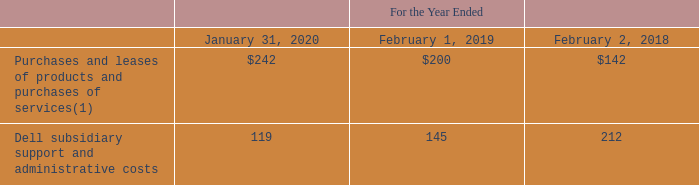We engaged with Dell in the following ongoing related party transactions, which resulted in costs to us:
• We purchase and lease products and purchase services from Dell.
• From time to time, we and Dell enter into agreements to collaborate on technology projects, and we pay Dell for services provided to us by Dell related to such projects.
• In certain geographic regions where we do not have an established legal entity, we contract with Dell subsidiaries for support services and support from Dell personnel who are managed by us. The costs incurred by Dell on our behalf related to these employees are charged to us with a mark-up intended to approximate costs that would have been incurred had we contracted for such services with an unrelated third party. These costs are included as expenses on our consolidated statements of income and primarily include salaries, benefits, travel and occupancy expenses. Dell also incurs certain administrative costs on our behalf in the U.S. that are recorded as expenses on our consolidated statements of income.
• In certain geographic regions, Dell files a consolidated indirect tax return, which includes value added taxes and other indirect taxes collected by us from our customers. We remit the indirect taxes to Dell and Dell remits the tax payment to the foreign governments on our behalf.
• From time to time, we invoice end users on behalf of Dell for certain services rendered by Dell. Cash related to these services is collected from the end user by us and remitted to Dell.
• From time to time, we also enter into agency arrangements with Dell that enable us to sell our subscriptions and services, leveraging the Dell enterprise relationships and end customer contracts.
Information about our payments for such arrangements during the periods presented consisted of the following (table in millions):
1) Amount includes indirect taxes that were remitted to Dell during the periods presented.
We also purchase Dell products through Dell’s channel partners. Purchases of Dell products through Dell’s channel partners were not significant during the periods presented.
Which years does the table provide information for the company's payment arrangements? 2020, 2019, 2018. What does Purchases and leases of products and purchases of services include? Indirect taxes that were remitted to dell during the periods presented. What was the Dell subsidiary support and administrative costs in 2019?
Answer scale should be: million. 145. What was the change in Purchases and leases of products and purchases of services between 2018 and 2019?
Answer scale should be: million. 200-142
Answer: 58. How many years did Dell subsidiary support and administrative costs exceed $200 million? 2018
Answer: 1. What was the percentage change in the Dell subsidiary support and administrative costs between 2019 and 2020?
Answer scale should be: percent. (119-145)/145
Answer: -17.93. 